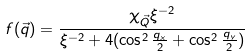<formula> <loc_0><loc_0><loc_500><loc_500>f ( \vec { q } ) = \frac { \chi _ { \vec { Q } } \xi ^ { - 2 } } { \xi ^ { - 2 } + 4 ( \cos ^ { 2 } \frac { q _ { x } } { 2 } + \cos ^ { 2 } \frac { q _ { y } } { 2 } ) }</formula> 